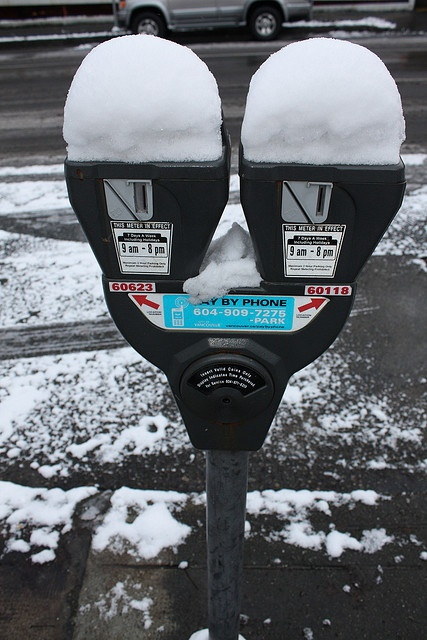Describe the objects in this image and their specific colors. I can see parking meter in gray, black, lightgray, and darkgray tones, parking meter in gray, black, lightgray, and darkgray tones, and car in gray, black, and darkgray tones in this image. 